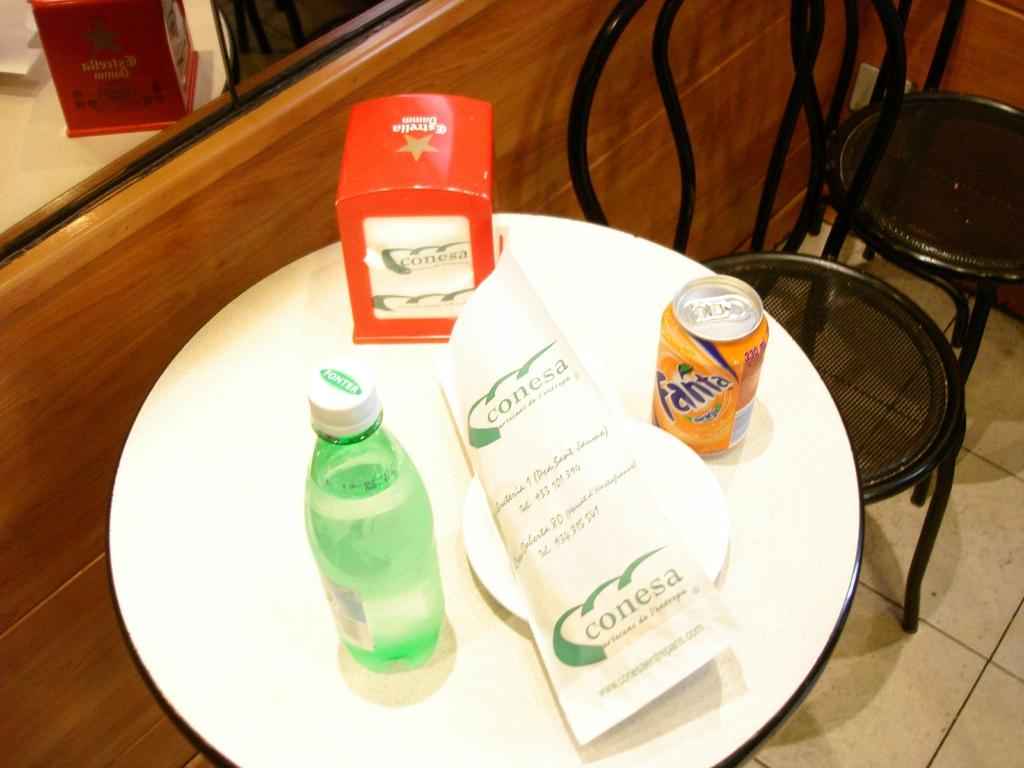Provide a one-sentence caption for the provided image. Wrapped conesa package on a white plate next to a fanta orange soda can seated on a round white table. 